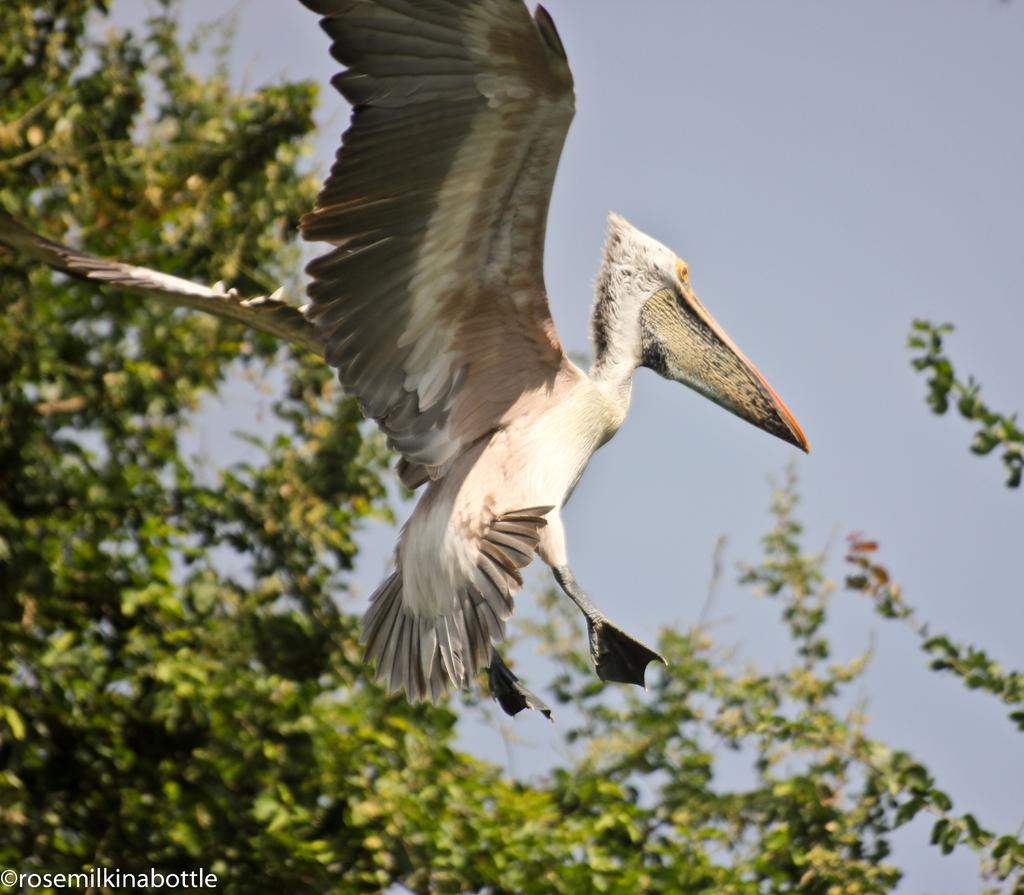What is the main subject of the image? There is a bird flying in the air in the image. What can be seen in the background of the image? There is a tree and the sky visible in the background of the image. Is there any text or marking in the image? Yes, there is a watermark in the bottom left corner of the image. Can you see any blood on the bird's feathers in the image? There is no blood visible on the bird's feathers in the image. Is it raining in the image? There is no indication of rain in the image; the sky appears to be clear. 